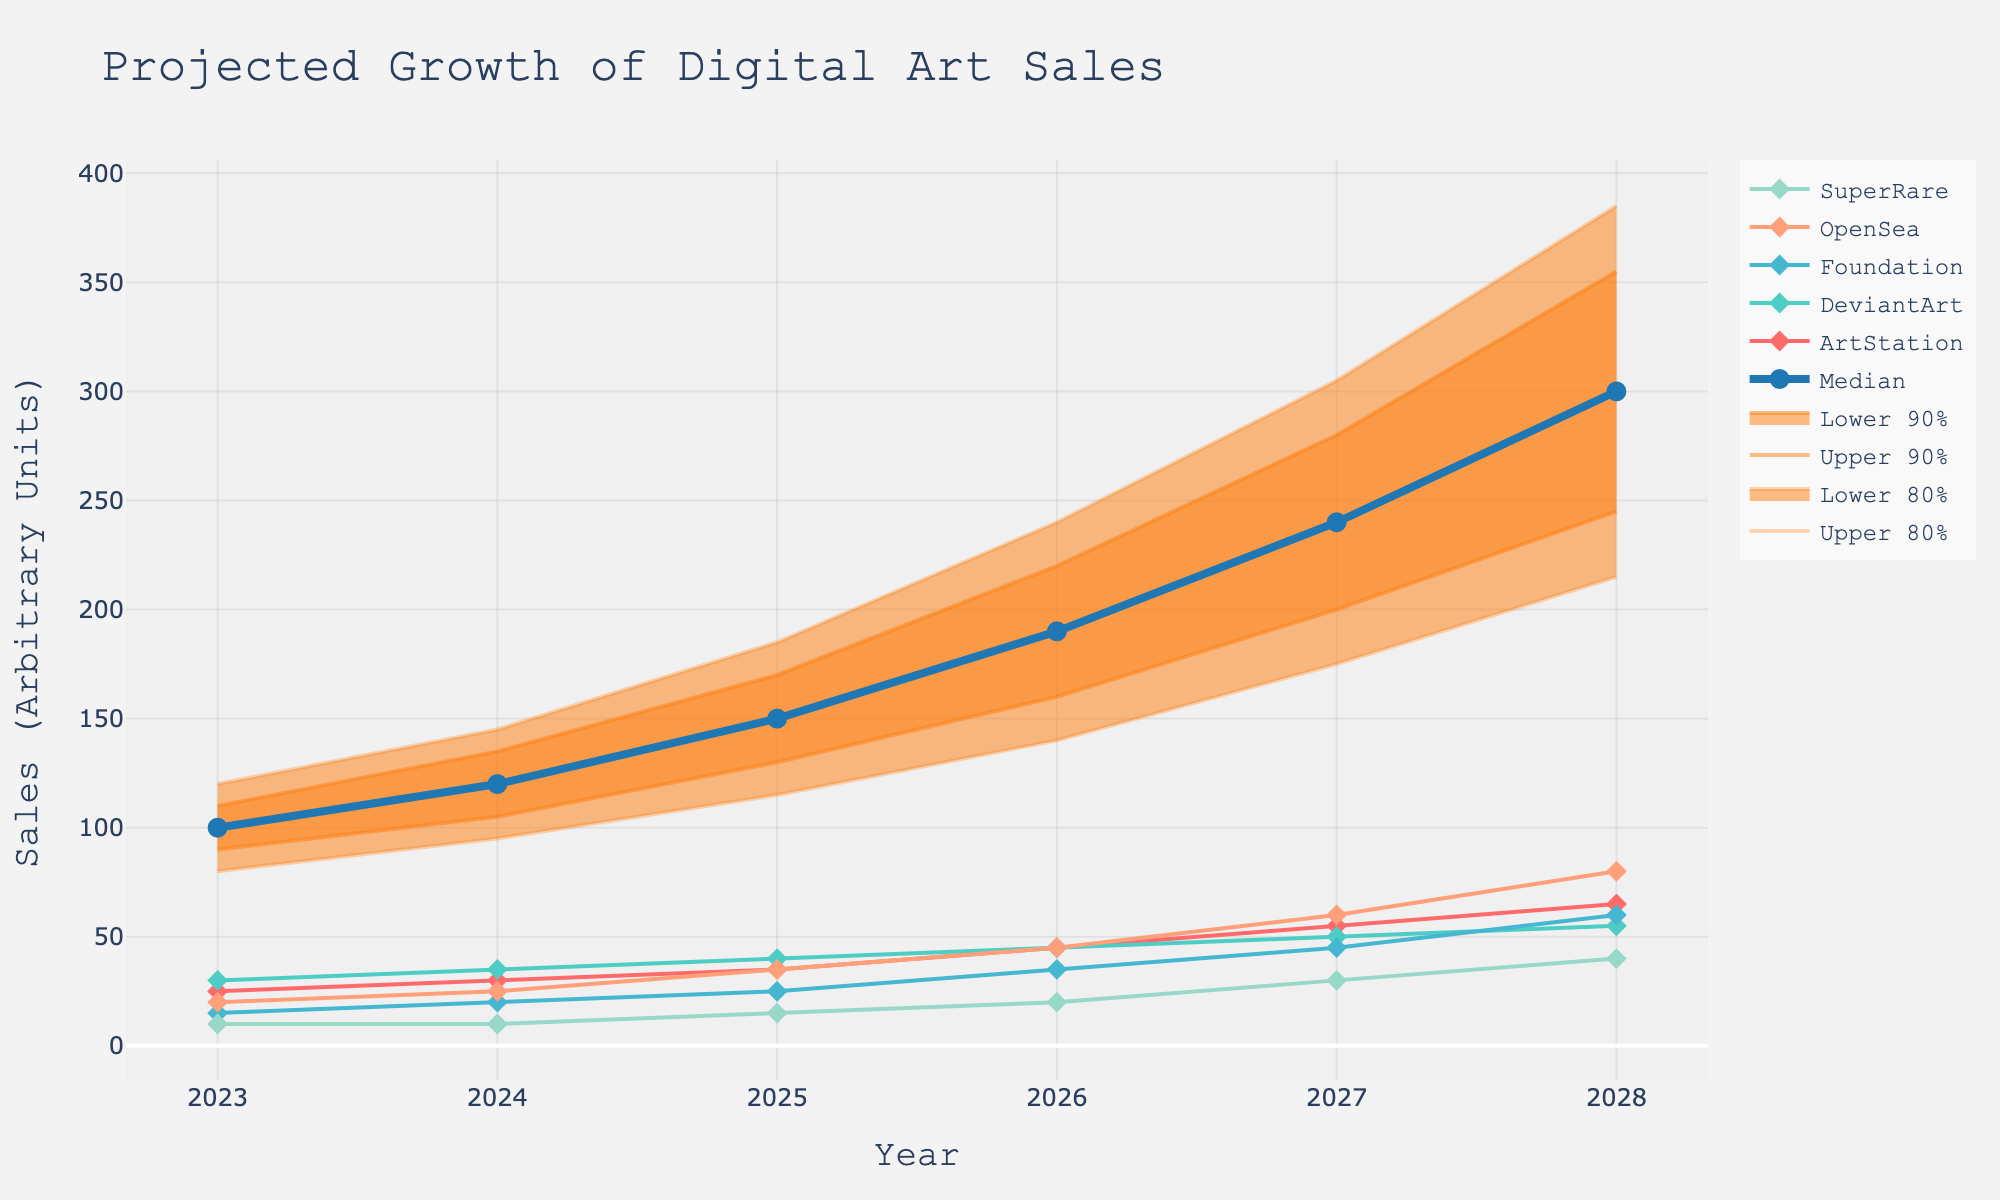What is the title of the chart? The title is located at the top of the chart and is usually in a larger font compared to other text. In this chart, it reads "Projected Growth of Digital Art Sales".
Answer: Projected Growth of Digital Art Sales What is the range of years displayed on the x-axis? The x-axis typically displays the range of years for the dataset. In this chart, the x-axis shows years from 2023 to 2028.
Answer: 2023 to 2028 How much is the median projected digital art sale valued in 2027? The median values of projected sales are marked by the line labeled 'Median.' Looking at the year 2027, the median value is shown at 240.
Answer: 240 Which platform is projected to have the highest sales in 2028? By comparing the value of each platform in 2028, OpenSea shows the highest sales value at 80 in 2028.
Answer: OpenSea Which year shows the widest uncertainty range (from Lower_20 to Upper_20) for projected digital art sales? The uncertainty range can be calculated by subtracting Lower_20 from Upper_20 for each year. The largest difference occurs in 2028, where the range is 385 - 215 = 170.
Answer: 2028 How does the projected median value change from 2024 to 2025? Referring to the median line, the median value in 2024 is 120 and in 2025 is 150. The change is 150 - 120 = 30.
Answer: Increase by 30 Between ArtStation and SuperRare, which platform shows a greater increase in projected sales from 2023 to 2028? For ArtStation, the change is 65 - 25 = 40. For SuperRare, the change is 40 - 10 = 30. ArtStation shows a greater increase.
Answer: ArtStation What's the predicted upper 10% sales value in 2026? The upper 10% sales value is identified by the upper boundary of the 90% confidence interval. For 2026, this value is 220.
Answer: 220 Which platform shows a consistently increasing trend from 2023 to 2028? By observing the trend lines for all platforms, both ArtStation and OpenSea show a consistent increase from 2023 to 2028. However, ArtStation has no flat or downward movement, indicating a constantly increasing trend.
Answer: ArtStation 